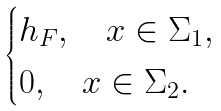<formula> <loc_0><loc_0><loc_500><loc_500>\begin{cases} h _ { F } , \quad x \in \Sigma _ { 1 } , \\ 0 , \quad x \in \Sigma _ { 2 } . \end{cases}</formula> 